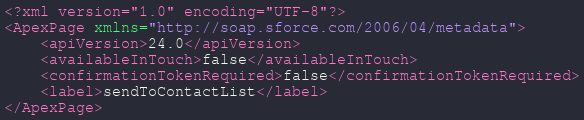<code> <loc_0><loc_0><loc_500><loc_500><_XML_><?xml version="1.0" encoding="UTF-8"?>
<ApexPage xmlns="http://soap.sforce.com/2006/04/metadata">
    <apiVersion>24.0</apiVersion>
    <availableInTouch>false</availableInTouch>
    <confirmationTokenRequired>false</confirmationTokenRequired>
    <label>sendToContactList</label>
</ApexPage>
</code> 